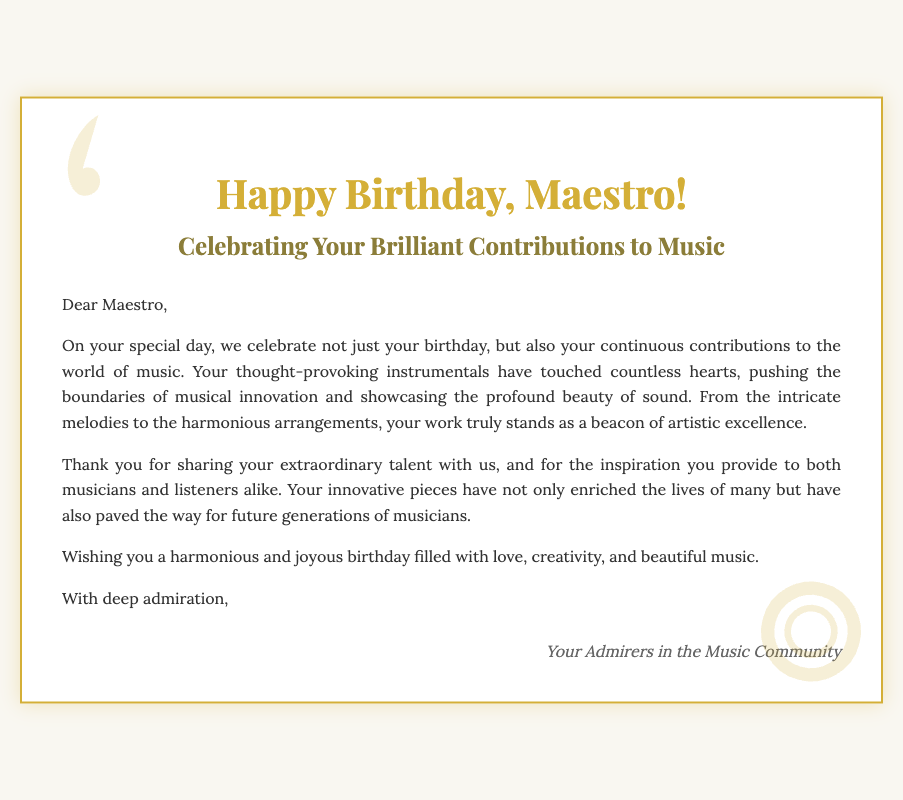What is the title of the card? The title of the card is prominently displayed at the top, which is "Happy Birthday, Maestro!".
Answer: Happy Birthday, Maestro! Who is the card addressed to? The document begins with a greeting "Dear Maestro," indicating that the card is directed towards a Maestro of music.
Answer: Maestro What is highlighted in the card's message? The message emphasizes the recipient's contributions to music and the impact of their instrumentals.
Answer: Contributions to music What color is used for the treble clef design? The treble clef is represented in golden color, as indicated by the style in the card's design.
Answer: Golden What is wished to the Maestro on their birthday? The card conveys a specific wish for the Maestro's birthday to be filled with certain experiences.
Answer: Harmonious and joyous birthday Who signed the card? The signature at the end of the card identifies the group who sent their wishes to the Maestro.
Answer: Your Admirers in the Music Community What is the primary theme of the card? The overall theme revolves around celebrating the Maestro's birthday while acknowledging their artistic influence and work.
Answer: Celebration of contributions How many paragraphs are there in the message? The message contains a specific number of paragraphs that convey the birthday wishes and sentiments.
Answer: Four paragraphs What type of design elements accompany the text on the card? The card features artistic musical symbols that enhance its visual appeal alongside the message.
Answer: Treble and bass clef designs 